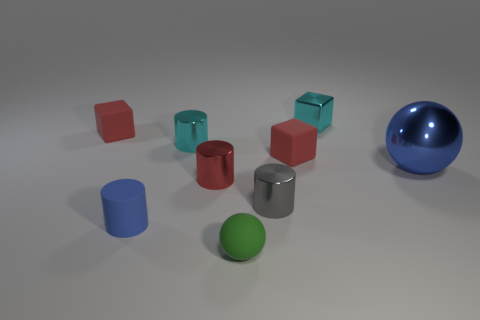Is there a small cylinder to the left of the small cyan shiny object on the left side of the cylinder right of the red metallic cylinder?
Keep it short and to the point. Yes. There is a cyan cylinder that is made of the same material as the large thing; what is its size?
Provide a succinct answer. Small. Are there any cyan metallic cylinders in front of the gray metal cylinder?
Your answer should be very brief. No. There is a tiny rubber sphere that is right of the tiny blue cylinder; are there any shiny spheres that are in front of it?
Ensure brevity in your answer.  No. Do the red matte thing that is to the left of the green rubber ball and the matte thing in front of the small blue matte thing have the same size?
Your answer should be very brief. Yes. What number of big things are yellow spheres or gray things?
Offer a terse response. 0. The red thing behind the metal cylinder that is on the left side of the red metal cylinder is made of what material?
Give a very brief answer. Rubber. What shape is the rubber thing that is the same color as the large shiny ball?
Offer a very short reply. Cylinder. Are there any small cyan spheres made of the same material as the small blue cylinder?
Keep it short and to the point. No. Is the material of the small blue cylinder the same as the cylinder that is behind the large blue sphere?
Your answer should be very brief. No. 